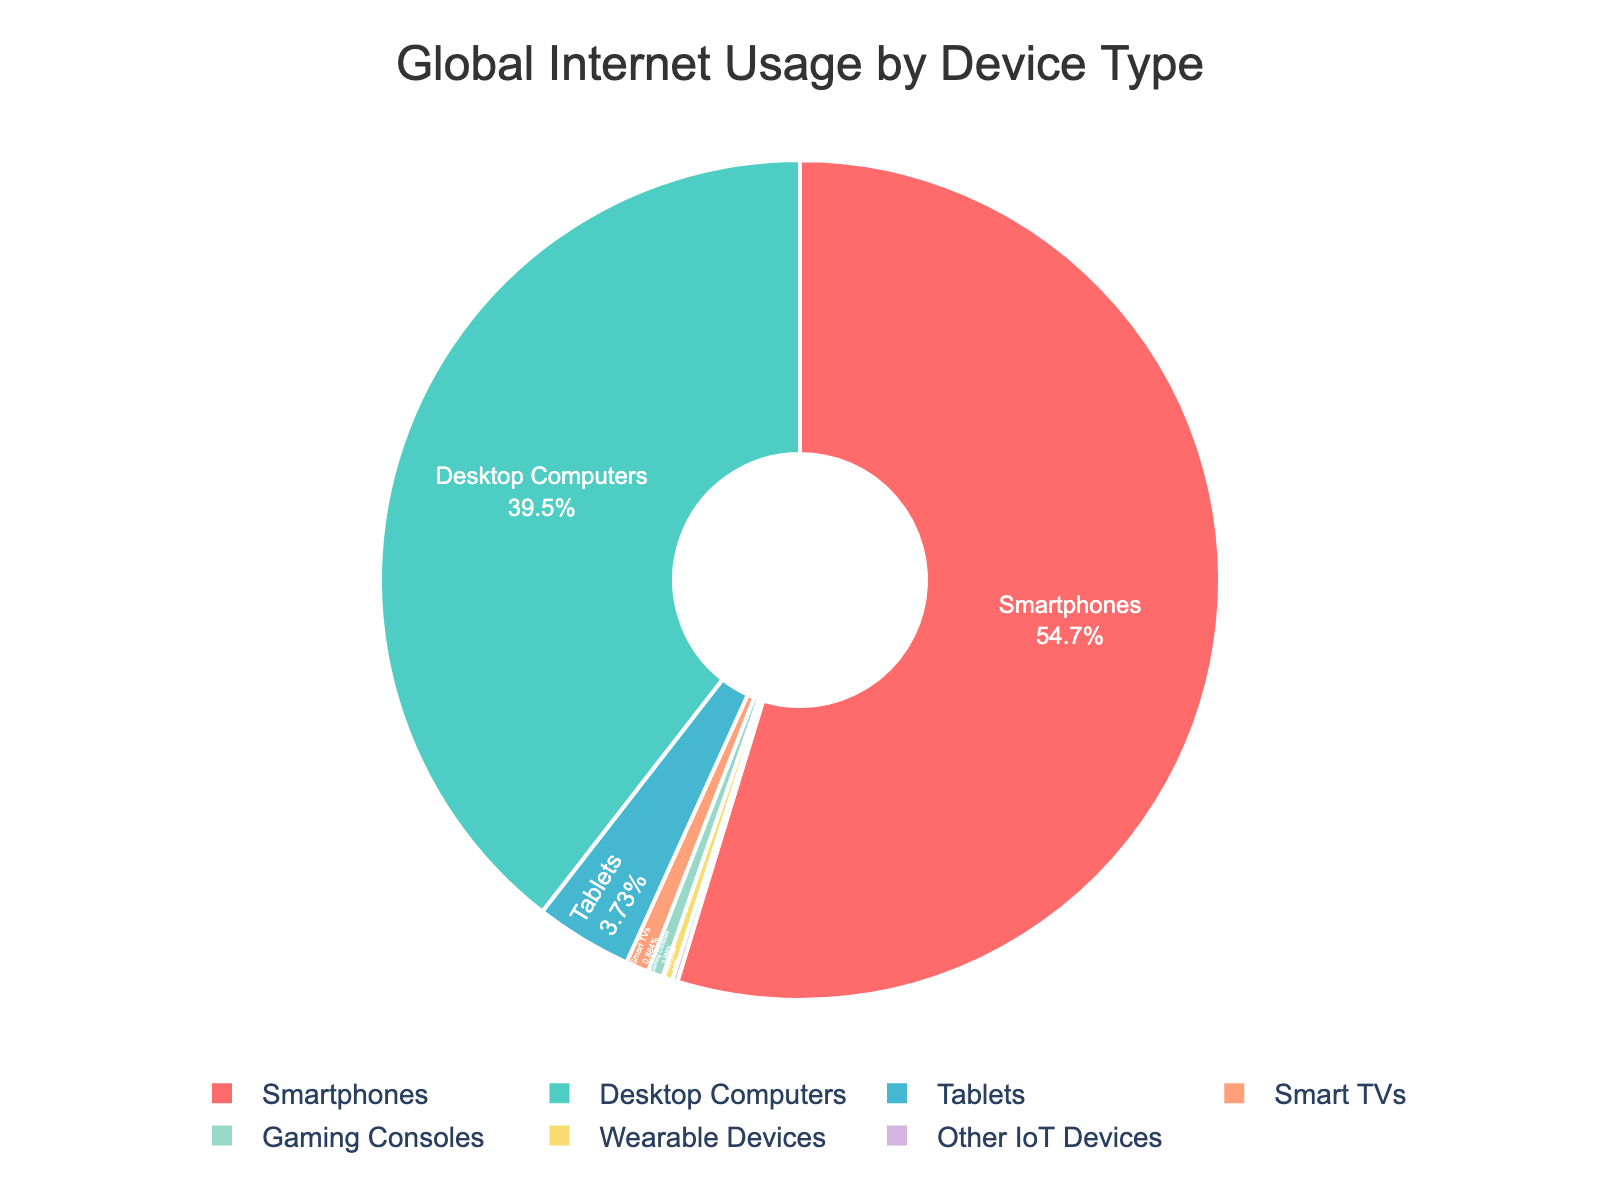What's the most used device for global internet usage? By looking at the pie chart, you can see that the device type with the largest section is labeled "Smartphones" with a percentage of 55.7%.
Answer: Smartphones Which device type has the smallest share of global internet usage? By observing the pie chart, the smallest section is labeled "Other IoT Devices" with a tiny percentage of 0.2%.
Answer: Other IoT Devices How much more percentage does smartphone usage have compared to desktop computers? The percentage for smartphones is 55.7% and for desktop computers, it is 40.2%. Subtracting these two values, 55.7% - 40.2% = 15.5%.
Answer: 15.5% What is the combined percentage of internet usage by tablets, smart TVs, and gaming consoles? Adding the percentages for tablets (3.8%), smart TVs (0.9%), and gaming consoles (0.6%), the sum is 3.8% + 0.9% + 0.6% = 5.3%.
Answer: 5.3% Are tablets used more for global internet usage than wearable devices? Yes, by looking at the pie chart, tablets have a percentage of 3.8% whereas wearable devices have 0.4% indicating that tablets are used more.
Answer: Yes Which device type has a percentage closest to 1%? Observing the pie chart, the device type closest to 1% is Smart TVs with a percentage of 0.9%.
Answer: Smart TVs What is the total percentage of internet usage attributable to both wearables and IoT devices? The percentage for wearable devices is 0.4% and for IoT devices, it is 0.2%. Adding these together, 0.4% + 0.2% = 0.6%.
Answer: 0.6% Is the percentage of desktop computer usage more or less than the combined percentage of tablets, smart TVs, and gaming consoles? The percentage for desktop computers is 40.2%. The combined percentage for tablets, smart TVs, and gaming consoles is 5.3%. 40.2% is more than 5.3%.
Answer: More Identify the two device types with the largest difference in internet usage percentage and state the difference. The highest percentage is for smartphones (55.7%) and the lowest is for Other IoT Devices (0.2%). The difference is 55.7% - 0.2% = 55.5%.
Answer: Smartphones and Other IoT Devices, 55.5% What color represents desktop computers in the pie chart? The pie chart has custom colors. From the list provided, desktop computers are represented by the second color, which is turquoise.
Answer: Turquoise 